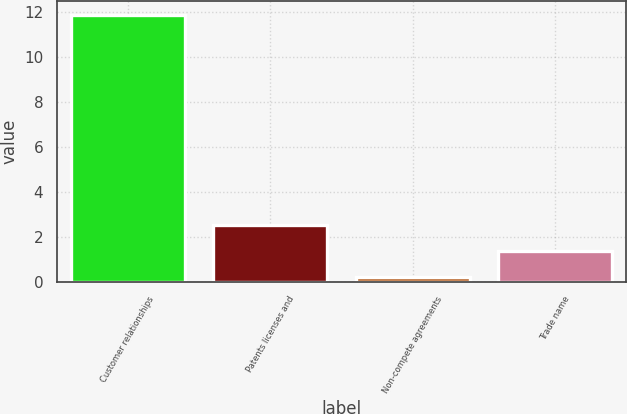Convert chart. <chart><loc_0><loc_0><loc_500><loc_500><bar_chart><fcel>Customer relationships<fcel>Patents licenses and<fcel>Non-compete agreements<fcel>Trade name<nl><fcel>11.9<fcel>2.54<fcel>0.2<fcel>1.37<nl></chart> 